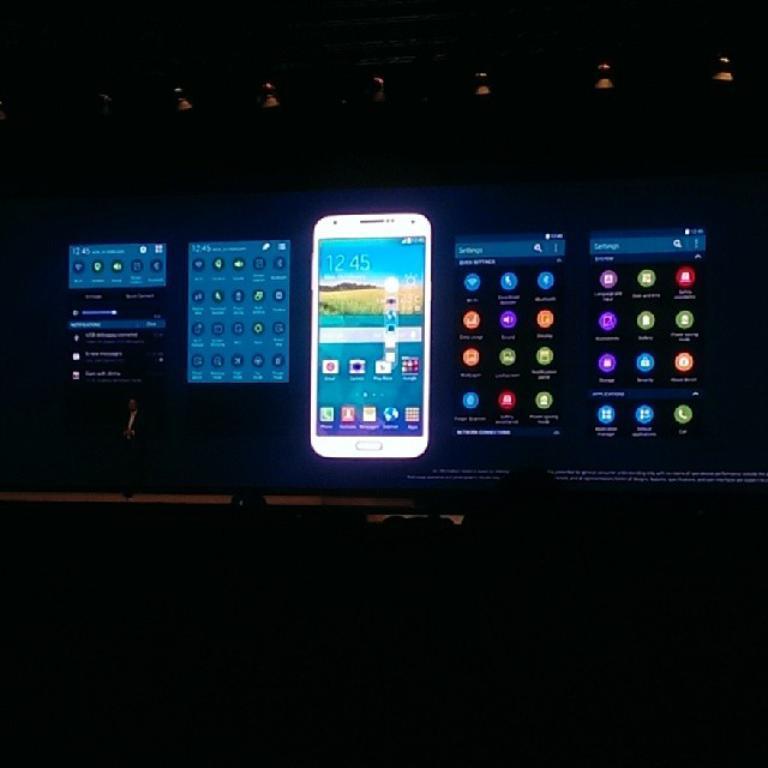How would you summarize this image in a sentence or two? Here in this picture we can see projector screen, on which we can see display options of a mobile phone presented and in front of it on the stage we can see a person standing over there and at the top we can see projectors present over there. 